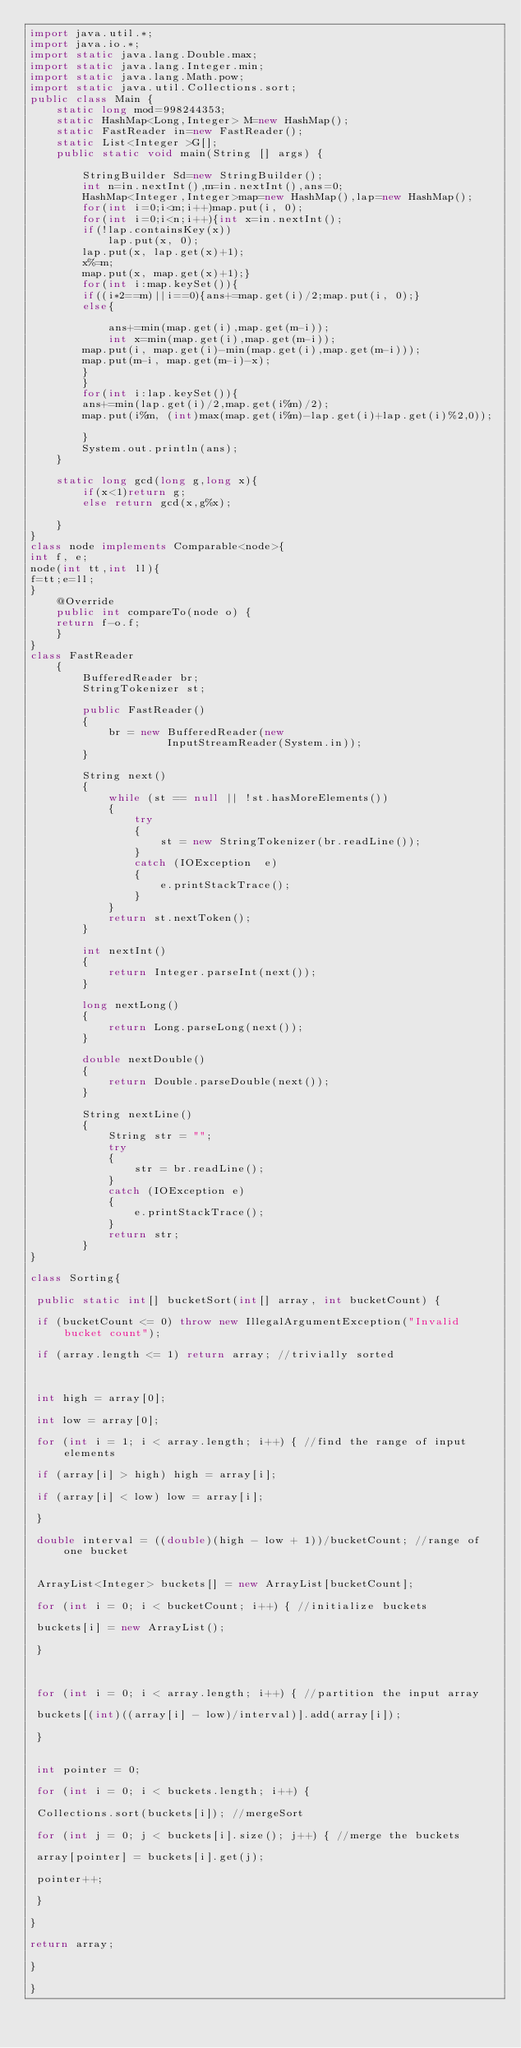Convert code to text. <code><loc_0><loc_0><loc_500><loc_500><_Java_>import java.util.*;
import java.io.*;
import static java.lang.Double.max;
import static java.lang.Integer.min;
import static java.lang.Math.pow;
import static java.util.Collections.sort;
public class Main {
    static long mod=998244353;
    static HashMap<Long,Integer> M=new HashMap();
    static FastReader in=new FastReader();
    static List<Integer >G[];
    public static void main(String [] args) {
        
        StringBuilder Sd=new StringBuilder();
        int n=in.nextInt(),m=in.nextInt(),ans=0;
        HashMap<Integer,Integer>map=new HashMap(),lap=new HashMap();
        for(int i=0;i<m;i++)map.put(i, 0);
        for(int i=0;i<n;i++){int x=in.nextInt();
        if(!lap.containsKey(x))
            lap.put(x, 0);
        lap.put(x, lap.get(x)+1);
        x%=m;
        map.put(x, map.get(x)+1);}
        for(int i:map.keySet()){
        if((i*2==m)||i==0){ans+=map.get(i)/2;map.put(i, 0);}
        else{
            
            ans+=min(map.get(i),map.get(m-i));
            int x=min(map.get(i),map.get(m-i));
        map.put(i, map.get(i)-min(map.get(i),map.get(m-i)));
        map.put(m-i, map.get(m-i)-x);
        }
        }
        for(int i:lap.keySet()){
        ans+=min(lap.get(i)/2,map.get(i%m)/2);
        map.put(i%m, (int)max(map.get(i%m)-lap.get(i)+lap.get(i)%2,0));
           
        }
        System.out.println(ans);
    }
    
    static long gcd(long g,long x){
        if(x<1)return g;
        else return gcd(x,g%x);
    
    }
}
class node implements Comparable<node>{
int f, e;
node(int tt,int ll){
f=tt;e=ll;
}
    @Override
    public int compareTo(node o) {
    return f-o.f;    
    }
}
class FastReader
    {
        BufferedReader br;
        StringTokenizer st;
 
        public FastReader()
        {
            br = new BufferedReader(new
                     InputStreamReader(System.in));
        }
 
        String next()
        {
            while (st == null || !st.hasMoreElements())
            {
                try
                {
                    st = new StringTokenizer(br.readLine());
                }
                catch (IOException  e)
                {
                    e.printStackTrace();
                }
            }
            return st.nextToken();
        }
 
        int nextInt()
        {
            return Integer.parseInt(next());
        }
 
        long nextLong()
        {
            return Long.parseLong(next());
        }
 
        double nextDouble()
        {
            return Double.parseDouble(next());
        }
 
        String nextLine()
        {
            String str = "";
            try
            {
                str = br.readLine();
            }
            catch (IOException e)
            {
                e.printStackTrace();
            }
            return str;
        }
}
 
class Sorting{
 
 public static int[] bucketSort(int[] array, int bucketCount) {
 
 if (bucketCount <= 0) throw new IllegalArgumentException("Invalid bucket count");
 
 if (array.length <= 1) return array; //trivially sorted
 
 
 
 int high = array[0];
 
 int low = array[0];
 
 for (int i = 1; i < array.length; i++) { //find the range of input elements
 
 if (array[i] > high) high = array[i];
 
 if (array[i] < low) low = array[i];
 
 }
 
 double interval = ((double)(high - low + 1))/bucketCount; //range of one bucket
 
 
 ArrayList<Integer> buckets[] = new ArrayList[bucketCount];
 
 for (int i = 0; i < bucketCount; i++) { //initialize buckets
 
 buckets[i] = new ArrayList();
 
 }
 
 
 
 for (int i = 0; i < array.length; i++) { //partition the input array
 
 buckets[(int)((array[i] - low)/interval)].add(array[i]);
 
 }
 
 
 int pointer = 0;
 
 for (int i = 0; i < buckets.length; i++) {
 
 Collections.sort(buckets[i]); //mergeSort
 
 for (int j = 0; j < buckets[i].size(); j++) { //merge the buckets
 
 array[pointer] = buckets[i].get(j);
 
 pointer++;
 
 }
 
}
 
return array;
 
}
 
}</code> 